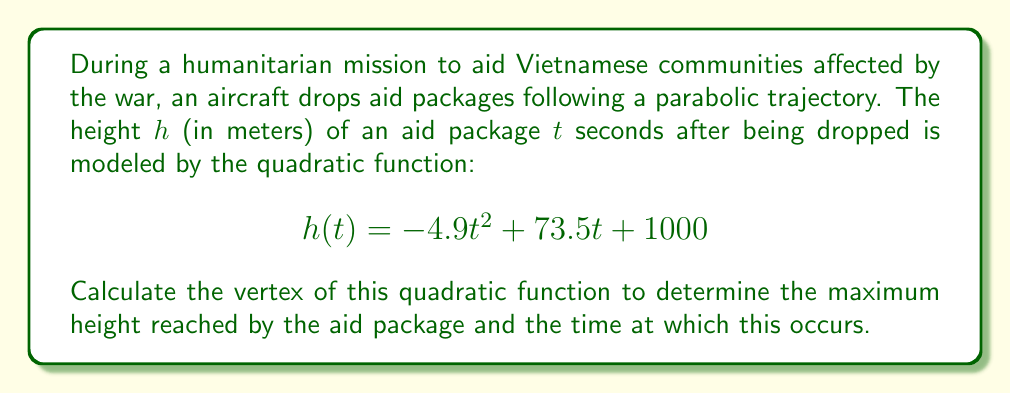Provide a solution to this math problem. To find the vertex of a quadratic function in the form $f(x) = ax^2 + bx + c$, we can use the formula:

$$x = -\frac{b}{2a}$$

Where $x$ is the $x$-coordinate of the vertex.

In this case, we have:
$a = -4.9$
$b = 73.5$
$c = 1000$

Let's calculate the $t$-coordinate (time) of the vertex:

$$t = -\frac{73.5}{2(-4.9)} = -\frac{73.5}{-9.8} = 7.5\text{ seconds}$$

To find the $h$-coordinate (height) of the vertex, we substitute this $t$ value into the original function:

$$\begin{align*}
h(7.5) &= -4.9(7.5)^2 + 73.5(7.5) + 1000 \\
&= -4.9(56.25) + 551.25 + 1000 \\
&= -275.625 + 551.25 + 1000 \\
&= 1275.625\text{ meters}
\end{align*}$$

Therefore, the vertex of the quadratic function is (7.5, 1275.625).
Answer: The vertex of the quadratic function is $(7.5, 1275.625)$. This means the aid package reaches its maximum height of 1275.625 meters after 7.5 seconds. 